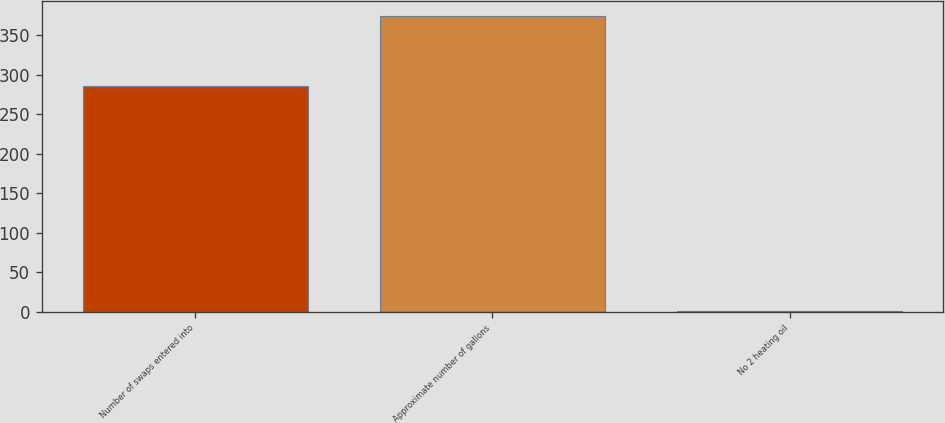<chart> <loc_0><loc_0><loc_500><loc_500><bar_chart><fcel>Number of swaps entered into<fcel>Approximate number of gallons<fcel>No 2 heating oil<nl><fcel>286<fcel>374<fcel>0.76<nl></chart> 